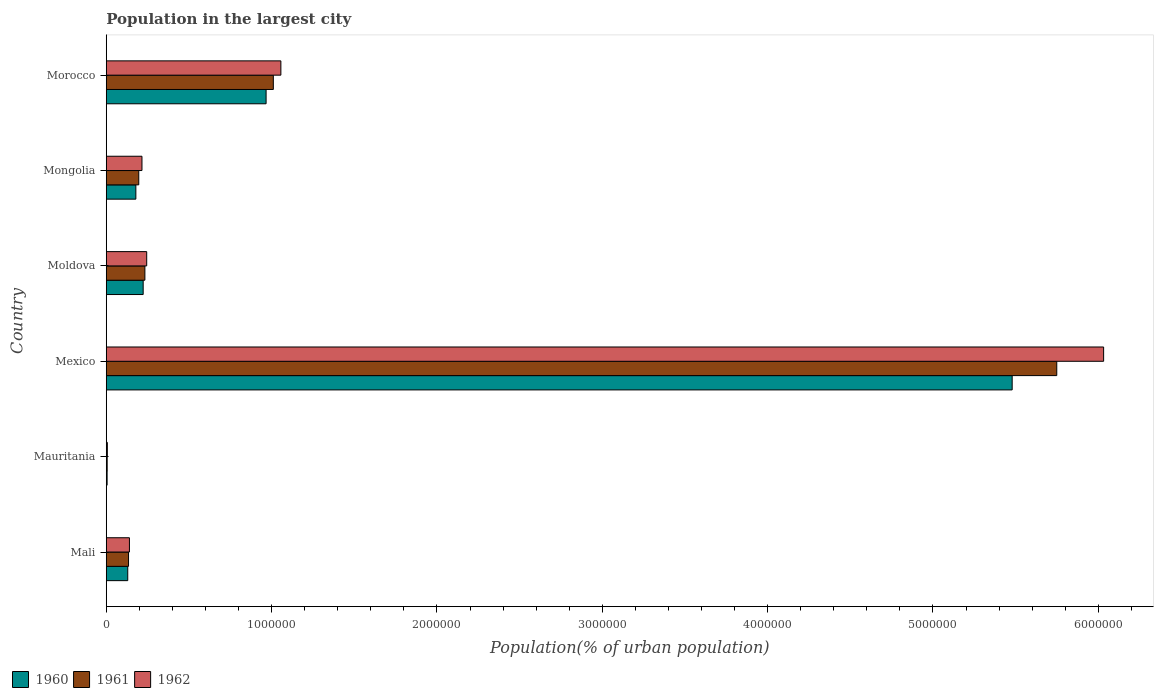How many different coloured bars are there?
Provide a short and direct response. 3. How many bars are there on the 3rd tick from the bottom?
Your answer should be very brief. 3. What is the population in the largest city in 1960 in Morocco?
Your response must be concise. 9.67e+05. Across all countries, what is the maximum population in the largest city in 1960?
Ensure brevity in your answer.  5.48e+06. Across all countries, what is the minimum population in the largest city in 1960?
Provide a short and direct response. 5254. In which country was the population in the largest city in 1960 minimum?
Your answer should be compact. Mauritania. What is the total population in the largest city in 1961 in the graph?
Offer a terse response. 7.33e+06. What is the difference between the population in the largest city in 1961 in Moldova and that in Morocco?
Your response must be concise. -7.77e+05. What is the difference between the population in the largest city in 1962 in Morocco and the population in the largest city in 1961 in Mali?
Offer a terse response. 9.21e+05. What is the average population in the largest city in 1960 per country?
Keep it short and to the point. 1.16e+06. What is the difference between the population in the largest city in 1960 and population in the largest city in 1962 in Mexico?
Offer a very short reply. -5.53e+05. In how many countries, is the population in the largest city in 1960 greater than 3800000 %?
Provide a succinct answer. 1. What is the ratio of the population in the largest city in 1961 in Mexico to that in Moldova?
Provide a succinct answer. 24.6. Is the population in the largest city in 1962 in Moldova less than that in Mongolia?
Your answer should be compact. No. What is the difference between the highest and the second highest population in the largest city in 1962?
Your answer should be compact. 4.98e+06. What is the difference between the highest and the lowest population in the largest city in 1962?
Make the answer very short. 6.03e+06. Is the sum of the population in the largest city in 1960 in Moldova and Morocco greater than the maximum population in the largest city in 1961 across all countries?
Make the answer very short. No. What does the 2nd bar from the top in Mongolia represents?
Your answer should be very brief. 1961. What does the 2nd bar from the bottom in Mongolia represents?
Your answer should be very brief. 1961. Are all the bars in the graph horizontal?
Your answer should be very brief. Yes. How many countries are there in the graph?
Make the answer very short. 6. What is the difference between two consecutive major ticks on the X-axis?
Make the answer very short. 1.00e+06. Does the graph contain grids?
Offer a very short reply. No. Where does the legend appear in the graph?
Give a very brief answer. Bottom left. How are the legend labels stacked?
Ensure brevity in your answer.  Horizontal. What is the title of the graph?
Your response must be concise. Population in the largest city. Does "1981" appear as one of the legend labels in the graph?
Offer a very short reply. No. What is the label or title of the X-axis?
Ensure brevity in your answer.  Population(% of urban population). What is the Population(% of urban population) of 1960 in Mali?
Provide a succinct answer. 1.30e+05. What is the Population(% of urban population) in 1961 in Mali?
Your answer should be very brief. 1.35e+05. What is the Population(% of urban population) in 1962 in Mali?
Offer a terse response. 1.40e+05. What is the Population(% of urban population) of 1960 in Mauritania?
Your answer should be compact. 5254. What is the Population(% of urban population) of 1961 in Mauritania?
Offer a very short reply. 5616. What is the Population(% of urban population) of 1962 in Mauritania?
Your answer should be very brief. 6603. What is the Population(% of urban population) of 1960 in Mexico?
Your response must be concise. 5.48e+06. What is the Population(% of urban population) of 1961 in Mexico?
Your answer should be compact. 5.75e+06. What is the Population(% of urban population) of 1962 in Mexico?
Give a very brief answer. 6.03e+06. What is the Population(% of urban population) in 1960 in Moldova?
Give a very brief answer. 2.23e+05. What is the Population(% of urban population) of 1961 in Moldova?
Your answer should be compact. 2.34e+05. What is the Population(% of urban population) in 1962 in Moldova?
Your answer should be very brief. 2.45e+05. What is the Population(% of urban population) of 1960 in Mongolia?
Your answer should be compact. 1.79e+05. What is the Population(% of urban population) of 1961 in Mongolia?
Your response must be concise. 1.97e+05. What is the Population(% of urban population) of 1962 in Mongolia?
Offer a terse response. 2.16e+05. What is the Population(% of urban population) in 1960 in Morocco?
Offer a terse response. 9.67e+05. What is the Population(% of urban population) in 1961 in Morocco?
Offer a very short reply. 1.01e+06. What is the Population(% of urban population) of 1962 in Morocco?
Your answer should be compact. 1.06e+06. Across all countries, what is the maximum Population(% of urban population) of 1960?
Offer a very short reply. 5.48e+06. Across all countries, what is the maximum Population(% of urban population) of 1961?
Provide a succinct answer. 5.75e+06. Across all countries, what is the maximum Population(% of urban population) of 1962?
Offer a terse response. 6.03e+06. Across all countries, what is the minimum Population(% of urban population) of 1960?
Offer a terse response. 5254. Across all countries, what is the minimum Population(% of urban population) of 1961?
Your answer should be very brief. 5616. Across all countries, what is the minimum Population(% of urban population) in 1962?
Keep it short and to the point. 6603. What is the total Population(% of urban population) of 1960 in the graph?
Offer a terse response. 6.98e+06. What is the total Population(% of urban population) of 1961 in the graph?
Your answer should be very brief. 7.33e+06. What is the total Population(% of urban population) of 1962 in the graph?
Make the answer very short. 7.70e+06. What is the difference between the Population(% of urban population) of 1960 in Mali and that in Mauritania?
Make the answer very short. 1.25e+05. What is the difference between the Population(% of urban population) of 1961 in Mali and that in Mauritania?
Your answer should be compact. 1.29e+05. What is the difference between the Population(% of urban population) in 1962 in Mali and that in Mauritania?
Keep it short and to the point. 1.34e+05. What is the difference between the Population(% of urban population) in 1960 in Mali and that in Mexico?
Offer a terse response. -5.35e+06. What is the difference between the Population(% of urban population) in 1961 in Mali and that in Mexico?
Your answer should be compact. -5.61e+06. What is the difference between the Population(% of urban population) in 1962 in Mali and that in Mexico?
Make the answer very short. -5.89e+06. What is the difference between the Population(% of urban population) in 1960 in Mali and that in Moldova?
Your answer should be compact. -9.33e+04. What is the difference between the Population(% of urban population) of 1961 in Mali and that in Moldova?
Your answer should be very brief. -9.89e+04. What is the difference between the Population(% of urban population) in 1962 in Mali and that in Moldova?
Ensure brevity in your answer.  -1.04e+05. What is the difference between the Population(% of urban population) of 1960 in Mali and that in Mongolia?
Your answer should be compact. -4.90e+04. What is the difference between the Population(% of urban population) in 1961 in Mali and that in Mongolia?
Provide a short and direct response. -6.19e+04. What is the difference between the Population(% of urban population) of 1962 in Mali and that in Mongolia?
Provide a short and direct response. -7.58e+04. What is the difference between the Population(% of urban population) of 1960 in Mali and that in Morocco?
Provide a succinct answer. -8.37e+05. What is the difference between the Population(% of urban population) in 1961 in Mali and that in Morocco?
Keep it short and to the point. -8.76e+05. What is the difference between the Population(% of urban population) in 1962 in Mali and that in Morocco?
Provide a succinct answer. -9.16e+05. What is the difference between the Population(% of urban population) of 1960 in Mauritania and that in Mexico?
Offer a very short reply. -5.47e+06. What is the difference between the Population(% of urban population) in 1961 in Mauritania and that in Mexico?
Offer a terse response. -5.74e+06. What is the difference between the Population(% of urban population) of 1962 in Mauritania and that in Mexico?
Keep it short and to the point. -6.03e+06. What is the difference between the Population(% of urban population) in 1960 in Mauritania and that in Moldova?
Provide a succinct answer. -2.18e+05. What is the difference between the Population(% of urban population) of 1961 in Mauritania and that in Moldova?
Offer a very short reply. -2.28e+05. What is the difference between the Population(% of urban population) in 1962 in Mauritania and that in Moldova?
Your answer should be compact. -2.38e+05. What is the difference between the Population(% of urban population) in 1960 in Mauritania and that in Mongolia?
Keep it short and to the point. -1.74e+05. What is the difference between the Population(% of urban population) of 1961 in Mauritania and that in Mongolia?
Provide a succinct answer. -1.91e+05. What is the difference between the Population(% of urban population) of 1962 in Mauritania and that in Mongolia?
Provide a short and direct response. -2.09e+05. What is the difference between the Population(% of urban population) of 1960 in Mauritania and that in Morocco?
Give a very brief answer. -9.62e+05. What is the difference between the Population(% of urban population) of 1961 in Mauritania and that in Morocco?
Offer a very short reply. -1.00e+06. What is the difference between the Population(% of urban population) in 1962 in Mauritania and that in Morocco?
Your answer should be compact. -1.05e+06. What is the difference between the Population(% of urban population) of 1960 in Mexico and that in Moldova?
Offer a terse response. 5.26e+06. What is the difference between the Population(% of urban population) in 1961 in Mexico and that in Moldova?
Give a very brief answer. 5.52e+06. What is the difference between the Population(% of urban population) in 1962 in Mexico and that in Moldova?
Keep it short and to the point. 5.79e+06. What is the difference between the Population(% of urban population) in 1960 in Mexico and that in Mongolia?
Your answer should be compact. 5.30e+06. What is the difference between the Population(% of urban population) of 1961 in Mexico and that in Mongolia?
Make the answer very short. 5.55e+06. What is the difference between the Population(% of urban population) in 1962 in Mexico and that in Mongolia?
Provide a short and direct response. 5.82e+06. What is the difference between the Population(% of urban population) in 1960 in Mexico and that in Morocco?
Provide a short and direct response. 4.51e+06. What is the difference between the Population(% of urban population) in 1961 in Mexico and that in Morocco?
Give a very brief answer. 4.74e+06. What is the difference between the Population(% of urban population) in 1962 in Mexico and that in Morocco?
Offer a terse response. 4.98e+06. What is the difference between the Population(% of urban population) in 1960 in Moldova and that in Mongolia?
Provide a succinct answer. 4.42e+04. What is the difference between the Population(% of urban population) of 1961 in Moldova and that in Mongolia?
Your response must be concise. 3.70e+04. What is the difference between the Population(% of urban population) of 1962 in Moldova and that in Mongolia?
Your answer should be compact. 2.86e+04. What is the difference between the Population(% of urban population) of 1960 in Moldova and that in Morocco?
Provide a short and direct response. -7.44e+05. What is the difference between the Population(% of urban population) of 1961 in Moldova and that in Morocco?
Make the answer very short. -7.77e+05. What is the difference between the Population(% of urban population) of 1962 in Moldova and that in Morocco?
Provide a short and direct response. -8.12e+05. What is the difference between the Population(% of urban population) of 1960 in Mongolia and that in Morocco?
Provide a short and direct response. -7.88e+05. What is the difference between the Population(% of urban population) in 1961 in Mongolia and that in Morocco?
Your answer should be very brief. -8.14e+05. What is the difference between the Population(% of urban population) of 1962 in Mongolia and that in Morocco?
Give a very brief answer. -8.40e+05. What is the difference between the Population(% of urban population) in 1960 in Mali and the Population(% of urban population) in 1961 in Mauritania?
Provide a short and direct response. 1.24e+05. What is the difference between the Population(% of urban population) in 1960 in Mali and the Population(% of urban population) in 1962 in Mauritania?
Provide a short and direct response. 1.23e+05. What is the difference between the Population(% of urban population) of 1961 in Mali and the Population(% of urban population) of 1962 in Mauritania?
Provide a short and direct response. 1.28e+05. What is the difference between the Population(% of urban population) of 1960 in Mali and the Population(% of urban population) of 1961 in Mexico?
Give a very brief answer. -5.62e+06. What is the difference between the Population(% of urban population) of 1960 in Mali and the Population(% of urban population) of 1962 in Mexico?
Keep it short and to the point. -5.90e+06. What is the difference between the Population(% of urban population) of 1961 in Mali and the Population(% of urban population) of 1962 in Mexico?
Give a very brief answer. -5.90e+06. What is the difference between the Population(% of urban population) in 1960 in Mali and the Population(% of urban population) in 1961 in Moldova?
Provide a succinct answer. -1.04e+05. What is the difference between the Population(% of urban population) in 1960 in Mali and the Population(% of urban population) in 1962 in Moldova?
Offer a terse response. -1.15e+05. What is the difference between the Population(% of urban population) in 1961 in Mali and the Population(% of urban population) in 1962 in Moldova?
Give a very brief answer. -1.10e+05. What is the difference between the Population(% of urban population) in 1960 in Mali and the Population(% of urban population) in 1961 in Mongolia?
Your answer should be very brief. -6.67e+04. What is the difference between the Population(% of urban population) in 1960 in Mali and the Population(% of urban population) in 1962 in Mongolia?
Offer a very short reply. -8.60e+04. What is the difference between the Population(% of urban population) of 1961 in Mali and the Population(% of urban population) of 1962 in Mongolia?
Provide a short and direct response. -8.13e+04. What is the difference between the Population(% of urban population) of 1960 in Mali and the Population(% of urban population) of 1961 in Morocco?
Your response must be concise. -8.80e+05. What is the difference between the Population(% of urban population) in 1960 in Mali and the Population(% of urban population) in 1962 in Morocco?
Provide a succinct answer. -9.26e+05. What is the difference between the Population(% of urban population) of 1961 in Mali and the Population(% of urban population) of 1962 in Morocco?
Make the answer very short. -9.21e+05. What is the difference between the Population(% of urban population) of 1960 in Mauritania and the Population(% of urban population) of 1961 in Mexico?
Your answer should be compact. -5.74e+06. What is the difference between the Population(% of urban population) of 1960 in Mauritania and the Population(% of urban population) of 1962 in Mexico?
Offer a very short reply. -6.03e+06. What is the difference between the Population(% of urban population) in 1961 in Mauritania and the Population(% of urban population) in 1962 in Mexico?
Your answer should be compact. -6.03e+06. What is the difference between the Population(% of urban population) in 1960 in Mauritania and the Population(% of urban population) in 1961 in Moldova?
Make the answer very short. -2.28e+05. What is the difference between the Population(% of urban population) of 1960 in Mauritania and the Population(% of urban population) of 1962 in Moldova?
Make the answer very short. -2.39e+05. What is the difference between the Population(% of urban population) of 1961 in Mauritania and the Population(% of urban population) of 1962 in Moldova?
Provide a short and direct response. -2.39e+05. What is the difference between the Population(% of urban population) in 1960 in Mauritania and the Population(% of urban population) in 1961 in Mongolia?
Give a very brief answer. -1.91e+05. What is the difference between the Population(% of urban population) in 1960 in Mauritania and the Population(% of urban population) in 1962 in Mongolia?
Your answer should be compact. -2.11e+05. What is the difference between the Population(% of urban population) in 1961 in Mauritania and the Population(% of urban population) in 1962 in Mongolia?
Give a very brief answer. -2.10e+05. What is the difference between the Population(% of urban population) in 1960 in Mauritania and the Population(% of urban population) in 1961 in Morocco?
Offer a terse response. -1.01e+06. What is the difference between the Population(% of urban population) in 1960 in Mauritania and the Population(% of urban population) in 1962 in Morocco?
Offer a terse response. -1.05e+06. What is the difference between the Population(% of urban population) of 1961 in Mauritania and the Population(% of urban population) of 1962 in Morocco?
Your answer should be very brief. -1.05e+06. What is the difference between the Population(% of urban population) of 1960 in Mexico and the Population(% of urban population) of 1961 in Moldova?
Provide a short and direct response. 5.25e+06. What is the difference between the Population(% of urban population) in 1960 in Mexico and the Population(% of urban population) in 1962 in Moldova?
Provide a succinct answer. 5.23e+06. What is the difference between the Population(% of urban population) of 1961 in Mexico and the Population(% of urban population) of 1962 in Moldova?
Ensure brevity in your answer.  5.50e+06. What is the difference between the Population(% of urban population) in 1960 in Mexico and the Population(% of urban population) in 1961 in Mongolia?
Your response must be concise. 5.28e+06. What is the difference between the Population(% of urban population) in 1960 in Mexico and the Population(% of urban population) in 1962 in Mongolia?
Give a very brief answer. 5.26e+06. What is the difference between the Population(% of urban population) in 1961 in Mexico and the Population(% of urban population) in 1962 in Mongolia?
Provide a succinct answer. 5.53e+06. What is the difference between the Population(% of urban population) in 1960 in Mexico and the Population(% of urban population) in 1961 in Morocco?
Provide a short and direct response. 4.47e+06. What is the difference between the Population(% of urban population) in 1960 in Mexico and the Population(% of urban population) in 1962 in Morocco?
Provide a short and direct response. 4.42e+06. What is the difference between the Population(% of urban population) in 1961 in Mexico and the Population(% of urban population) in 1962 in Morocco?
Offer a terse response. 4.69e+06. What is the difference between the Population(% of urban population) of 1960 in Moldova and the Population(% of urban population) of 1961 in Mongolia?
Give a very brief answer. 2.66e+04. What is the difference between the Population(% of urban population) of 1960 in Moldova and the Population(% of urban population) of 1962 in Mongolia?
Give a very brief answer. 7216. What is the difference between the Population(% of urban population) of 1961 in Moldova and the Population(% of urban population) of 1962 in Mongolia?
Provide a short and direct response. 1.77e+04. What is the difference between the Population(% of urban population) of 1960 in Moldova and the Population(% of urban population) of 1961 in Morocco?
Make the answer very short. -7.87e+05. What is the difference between the Population(% of urban population) in 1960 in Moldova and the Population(% of urban population) in 1962 in Morocco?
Offer a terse response. -8.33e+05. What is the difference between the Population(% of urban population) of 1961 in Moldova and the Population(% of urban population) of 1962 in Morocco?
Keep it short and to the point. -8.22e+05. What is the difference between the Population(% of urban population) in 1960 in Mongolia and the Population(% of urban population) in 1961 in Morocco?
Ensure brevity in your answer.  -8.31e+05. What is the difference between the Population(% of urban population) of 1960 in Mongolia and the Population(% of urban population) of 1962 in Morocco?
Offer a very short reply. -8.77e+05. What is the difference between the Population(% of urban population) in 1961 in Mongolia and the Population(% of urban population) in 1962 in Morocco?
Provide a short and direct response. -8.60e+05. What is the average Population(% of urban population) in 1960 per country?
Offer a terse response. 1.16e+06. What is the average Population(% of urban population) in 1961 per country?
Provide a succinct answer. 1.22e+06. What is the average Population(% of urban population) of 1962 per country?
Your answer should be compact. 1.28e+06. What is the difference between the Population(% of urban population) in 1960 and Population(% of urban population) in 1961 in Mali?
Keep it short and to the point. -4767. What is the difference between the Population(% of urban population) of 1960 and Population(% of urban population) of 1962 in Mali?
Provide a short and direct response. -1.02e+04. What is the difference between the Population(% of urban population) of 1961 and Population(% of urban population) of 1962 in Mali?
Your answer should be compact. -5483. What is the difference between the Population(% of urban population) in 1960 and Population(% of urban population) in 1961 in Mauritania?
Your answer should be very brief. -362. What is the difference between the Population(% of urban population) of 1960 and Population(% of urban population) of 1962 in Mauritania?
Your answer should be compact. -1349. What is the difference between the Population(% of urban population) of 1961 and Population(% of urban population) of 1962 in Mauritania?
Offer a very short reply. -987. What is the difference between the Population(% of urban population) in 1960 and Population(% of urban population) in 1961 in Mexico?
Your answer should be very brief. -2.70e+05. What is the difference between the Population(% of urban population) in 1960 and Population(% of urban population) in 1962 in Mexico?
Keep it short and to the point. -5.53e+05. What is the difference between the Population(% of urban population) in 1961 and Population(% of urban population) in 1962 in Mexico?
Your answer should be very brief. -2.83e+05. What is the difference between the Population(% of urban population) of 1960 and Population(% of urban population) of 1961 in Moldova?
Your answer should be compact. -1.04e+04. What is the difference between the Population(% of urban population) of 1960 and Population(% of urban population) of 1962 in Moldova?
Keep it short and to the point. -2.14e+04. What is the difference between the Population(% of urban population) of 1961 and Population(% of urban population) of 1962 in Moldova?
Offer a terse response. -1.09e+04. What is the difference between the Population(% of urban population) in 1960 and Population(% of urban population) in 1961 in Mongolia?
Provide a short and direct response. -1.76e+04. What is the difference between the Population(% of urban population) in 1960 and Population(% of urban population) in 1962 in Mongolia?
Give a very brief answer. -3.70e+04. What is the difference between the Population(% of urban population) of 1961 and Population(% of urban population) of 1962 in Mongolia?
Your response must be concise. -1.94e+04. What is the difference between the Population(% of urban population) in 1960 and Population(% of urban population) in 1961 in Morocco?
Your answer should be very brief. -4.37e+04. What is the difference between the Population(% of urban population) of 1960 and Population(% of urban population) of 1962 in Morocco?
Give a very brief answer. -8.94e+04. What is the difference between the Population(% of urban population) in 1961 and Population(% of urban population) in 1962 in Morocco?
Make the answer very short. -4.57e+04. What is the ratio of the Population(% of urban population) in 1960 in Mali to that in Mauritania?
Offer a very short reply. 24.75. What is the ratio of the Population(% of urban population) in 1962 in Mali to that in Mauritania?
Ensure brevity in your answer.  21.24. What is the ratio of the Population(% of urban population) in 1960 in Mali to that in Mexico?
Your response must be concise. 0.02. What is the ratio of the Population(% of urban population) in 1961 in Mali to that in Mexico?
Provide a succinct answer. 0.02. What is the ratio of the Population(% of urban population) of 1962 in Mali to that in Mexico?
Offer a terse response. 0.02. What is the ratio of the Population(% of urban population) in 1960 in Mali to that in Moldova?
Your answer should be compact. 0.58. What is the ratio of the Population(% of urban population) of 1961 in Mali to that in Moldova?
Give a very brief answer. 0.58. What is the ratio of the Population(% of urban population) of 1962 in Mali to that in Moldova?
Make the answer very short. 0.57. What is the ratio of the Population(% of urban population) of 1960 in Mali to that in Mongolia?
Provide a succinct answer. 0.73. What is the ratio of the Population(% of urban population) in 1961 in Mali to that in Mongolia?
Your answer should be compact. 0.69. What is the ratio of the Population(% of urban population) of 1962 in Mali to that in Mongolia?
Provide a short and direct response. 0.65. What is the ratio of the Population(% of urban population) of 1960 in Mali to that in Morocco?
Keep it short and to the point. 0.13. What is the ratio of the Population(% of urban population) of 1961 in Mali to that in Morocco?
Provide a short and direct response. 0.13. What is the ratio of the Population(% of urban population) in 1962 in Mali to that in Morocco?
Your answer should be very brief. 0.13. What is the ratio of the Population(% of urban population) of 1960 in Mauritania to that in Mexico?
Your response must be concise. 0. What is the ratio of the Population(% of urban population) of 1962 in Mauritania to that in Mexico?
Provide a succinct answer. 0. What is the ratio of the Population(% of urban population) in 1960 in Mauritania to that in Moldova?
Your response must be concise. 0.02. What is the ratio of the Population(% of urban population) in 1961 in Mauritania to that in Moldova?
Offer a very short reply. 0.02. What is the ratio of the Population(% of urban population) of 1962 in Mauritania to that in Moldova?
Give a very brief answer. 0.03. What is the ratio of the Population(% of urban population) in 1960 in Mauritania to that in Mongolia?
Ensure brevity in your answer.  0.03. What is the ratio of the Population(% of urban population) of 1961 in Mauritania to that in Mongolia?
Keep it short and to the point. 0.03. What is the ratio of the Population(% of urban population) in 1962 in Mauritania to that in Mongolia?
Your answer should be compact. 0.03. What is the ratio of the Population(% of urban population) of 1960 in Mauritania to that in Morocco?
Your answer should be very brief. 0.01. What is the ratio of the Population(% of urban population) of 1961 in Mauritania to that in Morocco?
Offer a terse response. 0.01. What is the ratio of the Population(% of urban population) in 1962 in Mauritania to that in Morocco?
Provide a succinct answer. 0.01. What is the ratio of the Population(% of urban population) of 1960 in Mexico to that in Moldova?
Give a very brief answer. 24.54. What is the ratio of the Population(% of urban population) of 1961 in Mexico to that in Moldova?
Provide a short and direct response. 24.6. What is the ratio of the Population(% of urban population) of 1962 in Mexico to that in Moldova?
Offer a very short reply. 24.65. What is the ratio of the Population(% of urban population) in 1960 in Mexico to that in Mongolia?
Your response must be concise. 30.6. What is the ratio of the Population(% of urban population) in 1961 in Mexico to that in Mongolia?
Your answer should be compact. 29.23. What is the ratio of the Population(% of urban population) of 1962 in Mexico to that in Mongolia?
Keep it short and to the point. 27.92. What is the ratio of the Population(% of urban population) in 1960 in Mexico to that in Morocco?
Your answer should be very brief. 5.67. What is the ratio of the Population(% of urban population) in 1961 in Mexico to that in Morocco?
Make the answer very short. 5.69. What is the ratio of the Population(% of urban population) in 1962 in Mexico to that in Morocco?
Your response must be concise. 5.71. What is the ratio of the Population(% of urban population) of 1960 in Moldova to that in Mongolia?
Give a very brief answer. 1.25. What is the ratio of the Population(% of urban population) of 1961 in Moldova to that in Mongolia?
Make the answer very short. 1.19. What is the ratio of the Population(% of urban population) of 1962 in Moldova to that in Mongolia?
Your response must be concise. 1.13. What is the ratio of the Population(% of urban population) in 1960 in Moldova to that in Morocco?
Your response must be concise. 0.23. What is the ratio of the Population(% of urban population) in 1961 in Moldova to that in Morocco?
Your response must be concise. 0.23. What is the ratio of the Population(% of urban population) in 1962 in Moldova to that in Morocco?
Ensure brevity in your answer.  0.23. What is the ratio of the Population(% of urban population) in 1960 in Mongolia to that in Morocco?
Offer a very short reply. 0.19. What is the ratio of the Population(% of urban population) of 1961 in Mongolia to that in Morocco?
Make the answer very short. 0.19. What is the ratio of the Population(% of urban population) of 1962 in Mongolia to that in Morocco?
Keep it short and to the point. 0.2. What is the difference between the highest and the second highest Population(% of urban population) of 1960?
Offer a very short reply. 4.51e+06. What is the difference between the highest and the second highest Population(% of urban population) of 1961?
Make the answer very short. 4.74e+06. What is the difference between the highest and the second highest Population(% of urban population) in 1962?
Ensure brevity in your answer.  4.98e+06. What is the difference between the highest and the lowest Population(% of urban population) in 1960?
Make the answer very short. 5.47e+06. What is the difference between the highest and the lowest Population(% of urban population) of 1961?
Offer a very short reply. 5.74e+06. What is the difference between the highest and the lowest Population(% of urban population) in 1962?
Offer a very short reply. 6.03e+06. 